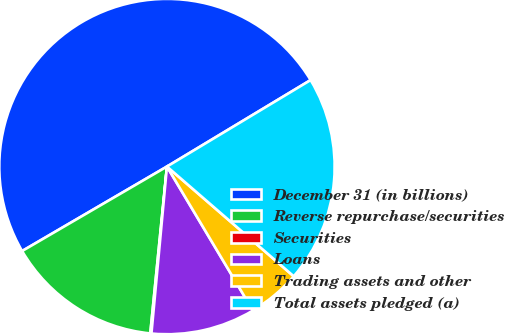Convert chart. <chart><loc_0><loc_0><loc_500><loc_500><pie_chart><fcel>December 31 (in billions)<fcel>Reverse repurchase/securities<fcel>Securities<fcel>Loans<fcel>Trading assets and other<fcel>Total assets pledged (a)<nl><fcel>49.78%<fcel>15.01%<fcel>0.11%<fcel>10.04%<fcel>5.08%<fcel>19.98%<nl></chart> 